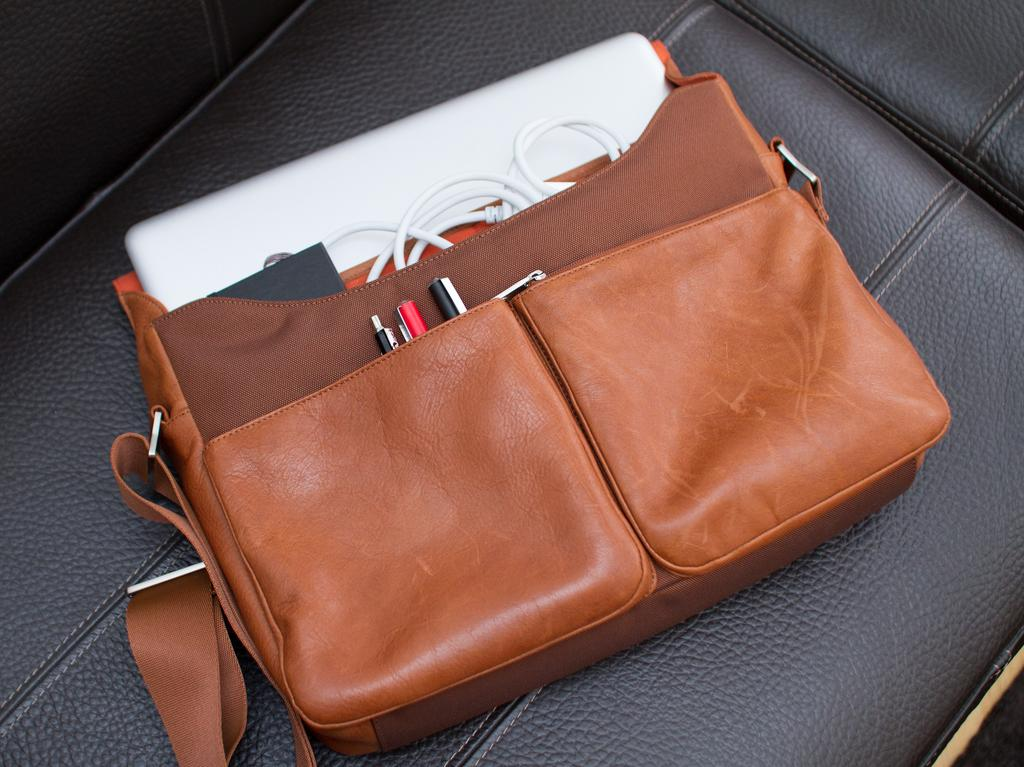What is placed on the seat in the image? There is a bag on the seat. What is the color of the bag? The bag is brown in color. What items can be found inside the bag? There are pens, a wire, and a laptop in the bag. How much income does the pail generate in the image? There is no pail present in the image, so it is not possible to determine its income. 